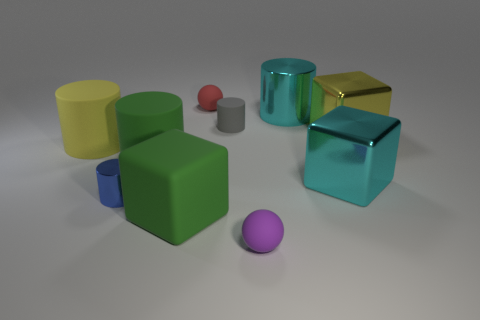Subtract 2 cylinders. How many cylinders are left? 3 Subtract all yellow cylinders. How many cylinders are left? 4 Subtract all tiny blue cylinders. How many cylinders are left? 4 Subtract all brown cylinders. Subtract all yellow balls. How many cylinders are left? 5 Subtract all balls. How many objects are left? 8 Subtract all red matte balls. Subtract all matte cylinders. How many objects are left? 6 Add 2 big cyan cylinders. How many big cyan cylinders are left? 3 Add 2 red metallic objects. How many red metallic objects exist? 2 Subtract 0 purple cylinders. How many objects are left? 10 